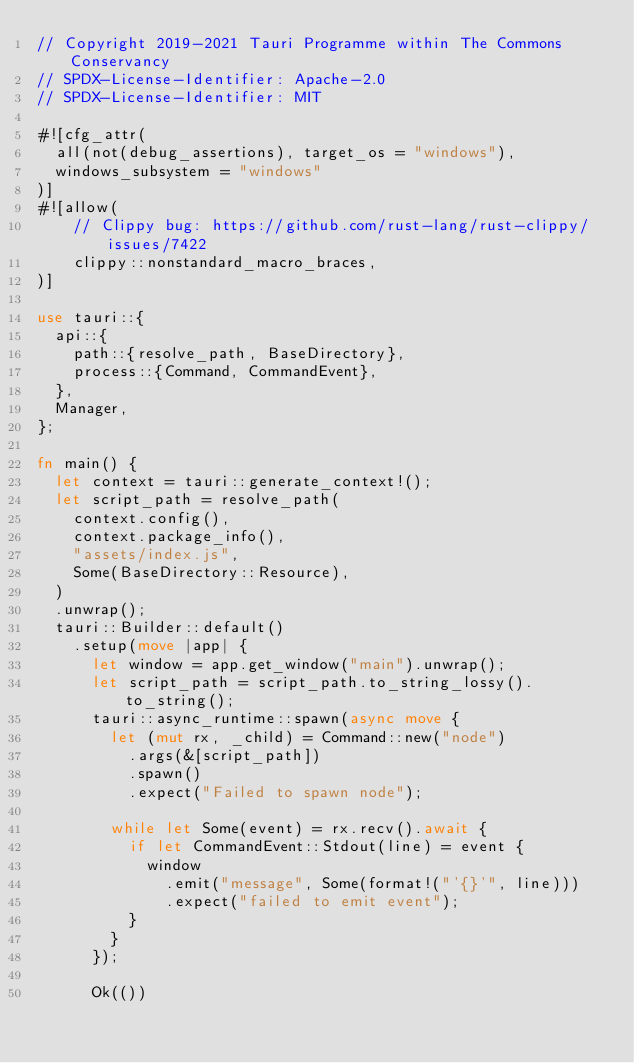<code> <loc_0><loc_0><loc_500><loc_500><_Rust_>// Copyright 2019-2021 Tauri Programme within The Commons Conservancy
// SPDX-License-Identifier: Apache-2.0
// SPDX-License-Identifier: MIT

#![cfg_attr(
  all(not(debug_assertions), target_os = "windows"),
  windows_subsystem = "windows"
)]
#![allow(
    // Clippy bug: https://github.com/rust-lang/rust-clippy/issues/7422
    clippy::nonstandard_macro_braces,
)]

use tauri::{
  api::{
    path::{resolve_path, BaseDirectory},
    process::{Command, CommandEvent},
  },
  Manager,
};

fn main() {
  let context = tauri::generate_context!();
  let script_path = resolve_path(
    context.config(),
    context.package_info(),
    "assets/index.js",
    Some(BaseDirectory::Resource),
  )
  .unwrap();
  tauri::Builder::default()
    .setup(move |app| {
      let window = app.get_window("main").unwrap();
      let script_path = script_path.to_string_lossy().to_string();
      tauri::async_runtime::spawn(async move {
        let (mut rx, _child) = Command::new("node")
          .args(&[script_path])
          .spawn()
          .expect("Failed to spawn node");

        while let Some(event) = rx.recv().await {
          if let CommandEvent::Stdout(line) = event {
            window
              .emit("message", Some(format!("'{}'", line)))
              .expect("failed to emit event");
          }
        }
      });

      Ok(())</code> 